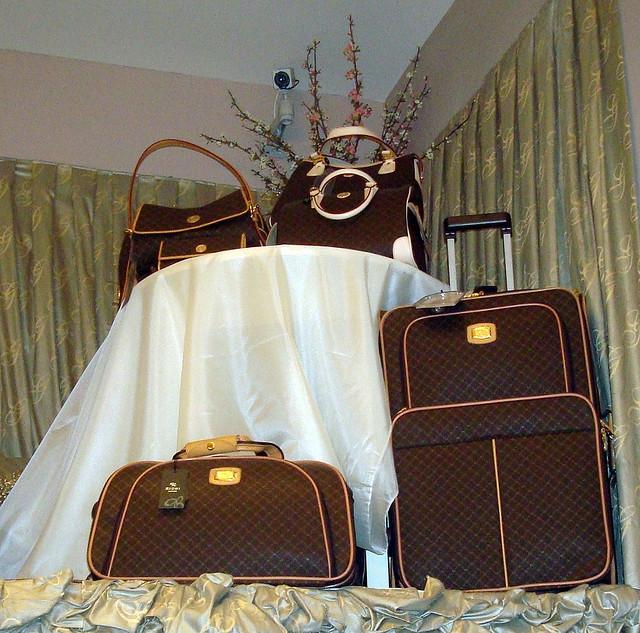Are the luggages made of the same material?
Give a very brief answer. Yes. How many pieces of luggage is there?
Give a very brief answer. 4. What is the purpose of the electronic at the top of the photo?
Write a very short answer. Surveillance. 